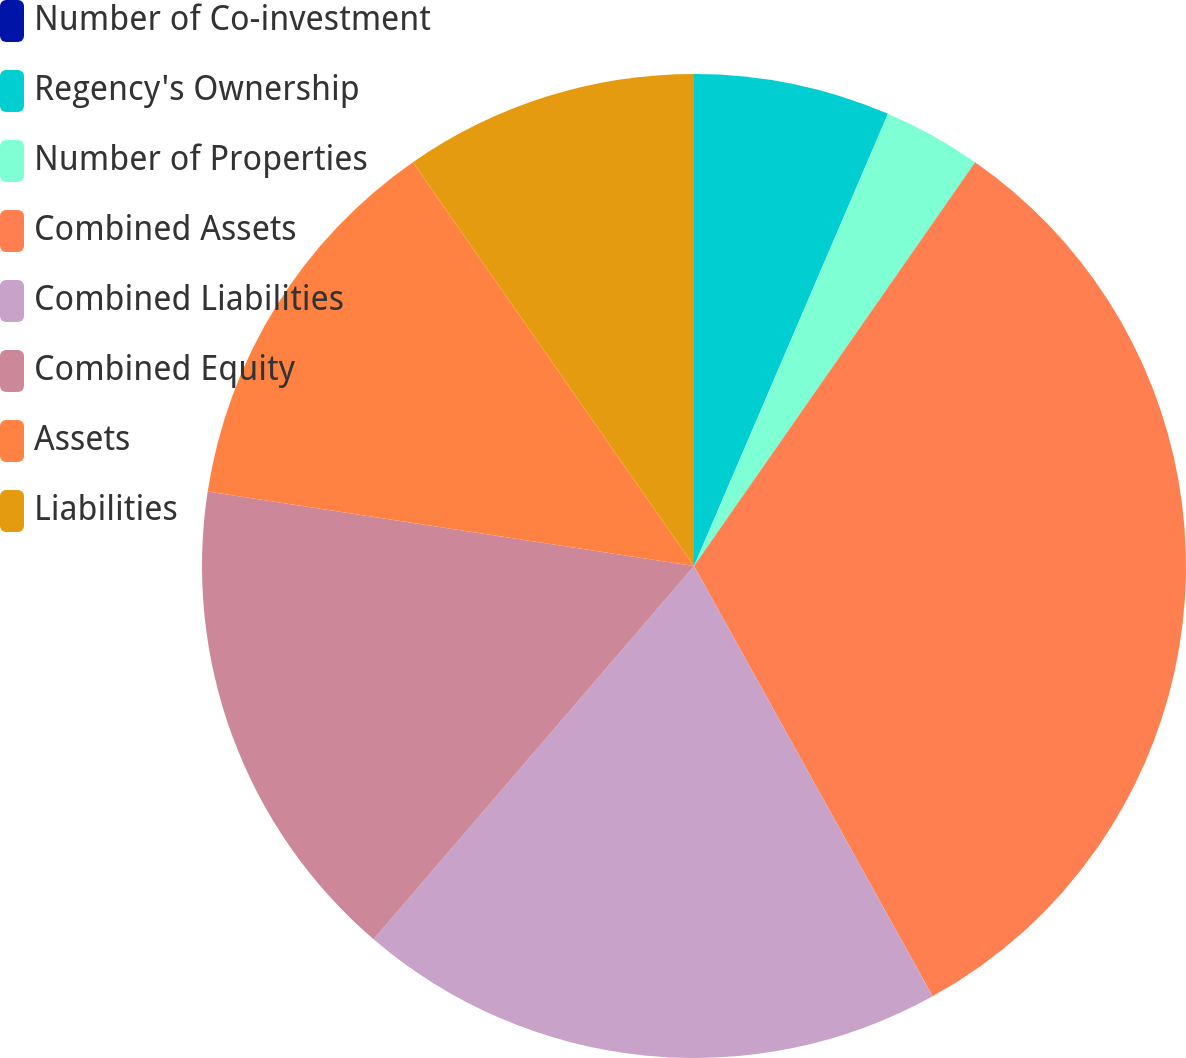Convert chart to OTSL. <chart><loc_0><loc_0><loc_500><loc_500><pie_chart><fcel>Number of Co-investment<fcel>Regency's Ownership<fcel>Number of Properties<fcel>Combined Assets<fcel>Combined Liabilities<fcel>Combined Equity<fcel>Assets<fcel>Liabilities<nl><fcel>0.0%<fcel>6.45%<fcel>3.23%<fcel>32.26%<fcel>19.35%<fcel>16.13%<fcel>12.9%<fcel>9.68%<nl></chart> 